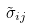Convert formula to latex. <formula><loc_0><loc_0><loc_500><loc_500>\tilde { \sigma } _ { i j }</formula> 